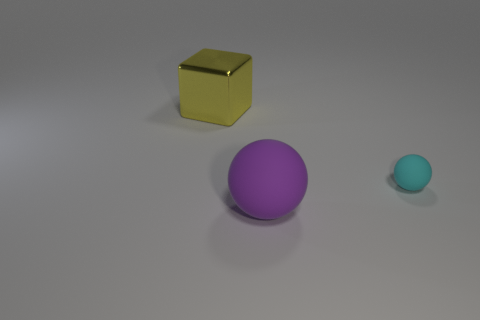Is there anything else that has the same material as the yellow block?
Offer a terse response. No. What is the material of the big object left of the big matte sphere?
Make the answer very short. Metal. How many spheres are either big purple objects or tiny things?
Provide a succinct answer. 2. Is the number of rubber balls to the left of the big purple thing the same as the number of big rubber balls behind the large yellow thing?
Make the answer very short. Yes. There is a yellow metallic thing that is behind the sphere that is right of the big sphere; what number of big objects are on the right side of it?
Offer a terse response. 1. Are there more large objects in front of the tiny sphere than cyan shiny things?
Your answer should be very brief. Yes. What number of things are either things to the right of the block or balls left of the cyan rubber thing?
Offer a terse response. 2. There is a cyan object that is made of the same material as the purple object; what size is it?
Keep it short and to the point. Small. There is a rubber object behind the large purple thing; is it the same shape as the large purple matte object?
Keep it short and to the point. Yes. What number of cyan things are either small spheres or small cylinders?
Keep it short and to the point. 1. 